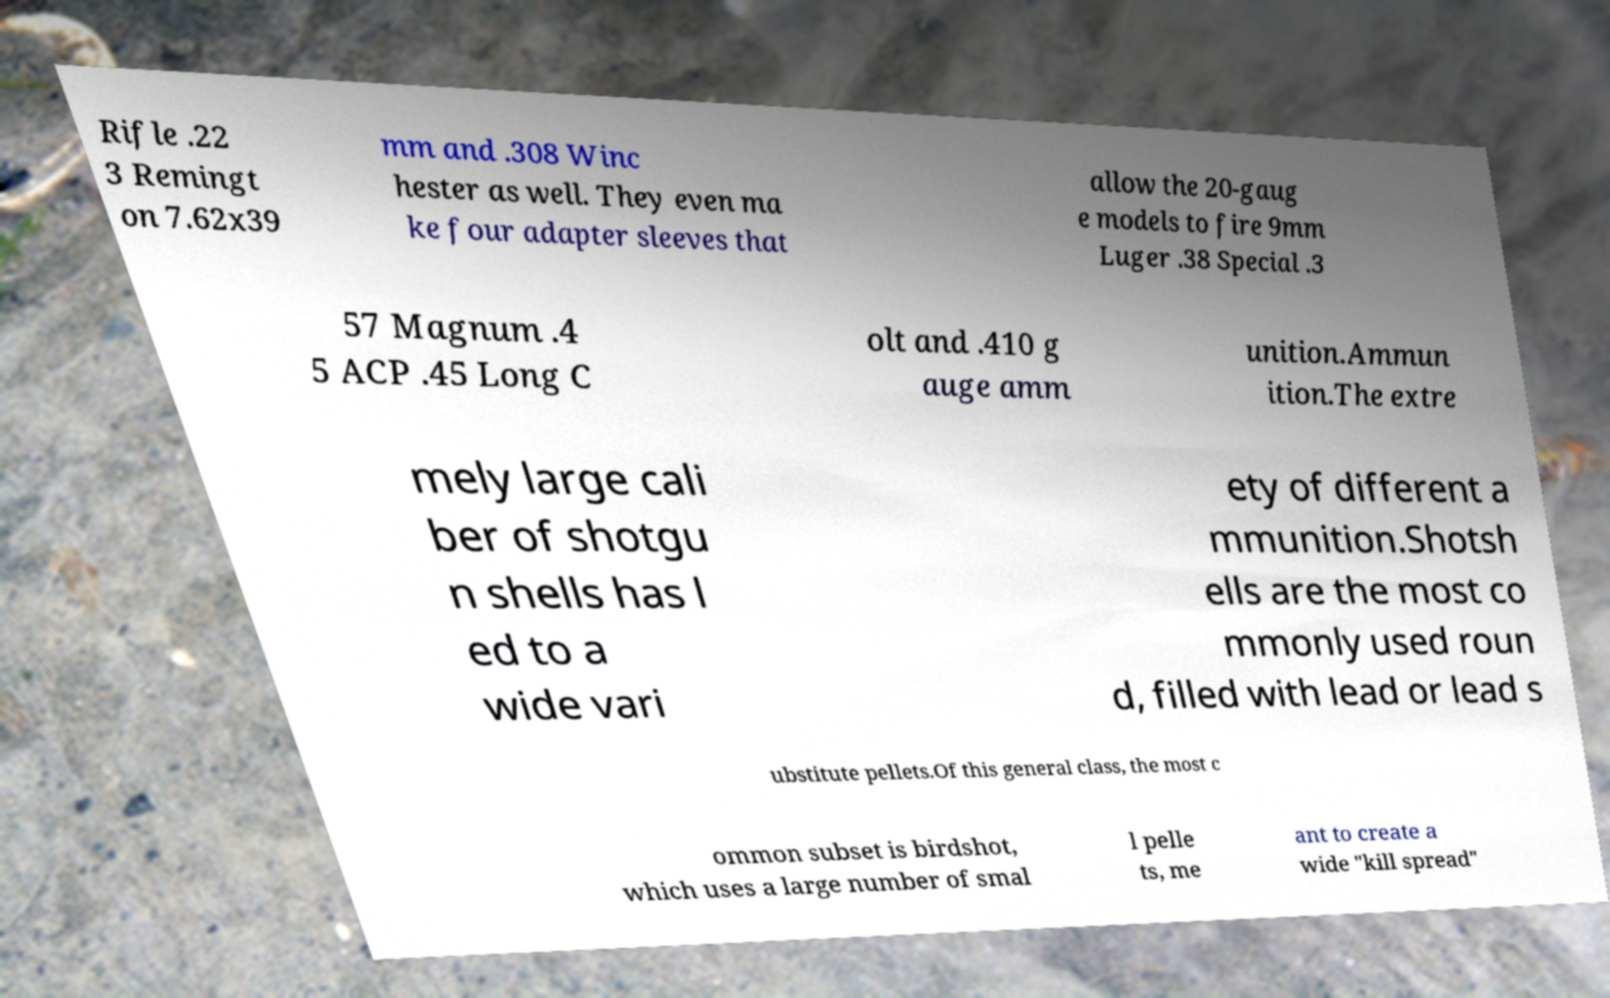I need the written content from this picture converted into text. Can you do that? Rifle .22 3 Remingt on 7.62x39 mm and .308 Winc hester as well. They even ma ke four adapter sleeves that allow the 20-gaug e models to fire 9mm Luger .38 Special .3 57 Magnum .4 5 ACP .45 Long C olt and .410 g auge amm unition.Ammun ition.The extre mely large cali ber of shotgu n shells has l ed to a wide vari ety of different a mmunition.Shotsh ells are the most co mmonly used roun d, filled with lead or lead s ubstitute pellets.Of this general class, the most c ommon subset is birdshot, which uses a large number of smal l pelle ts, me ant to create a wide "kill spread" 